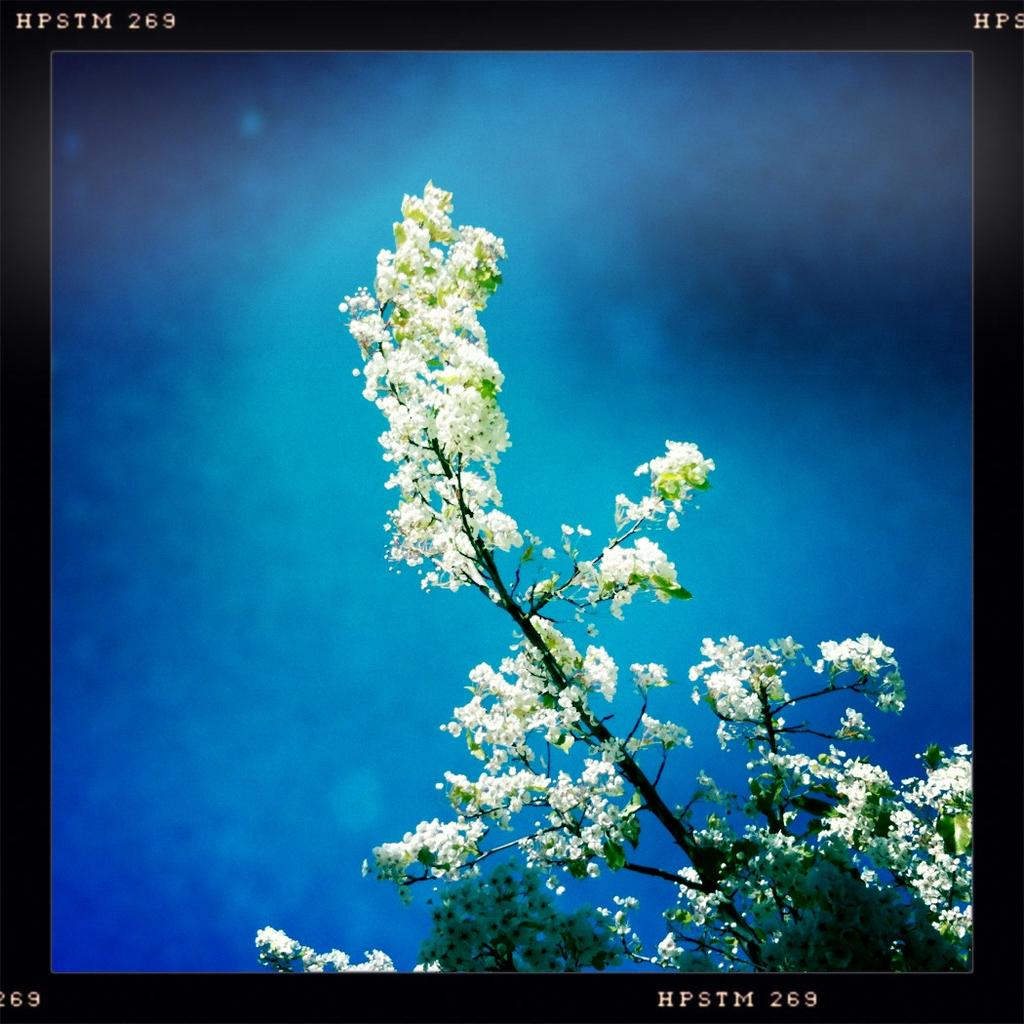What is the main subject of the image? The main subject of the image is a tree with many flowers on it. Can you describe the background of the image? The background of the image is blurred. What is present at the top and bottom of the image? There is some text at the top and bottom of the image. Are there any dinosaurs visible in the image? No, there are no dinosaurs present in the image. Can you see a snake slithering through the flowers on the tree? No, there is no snake visible in the image. 